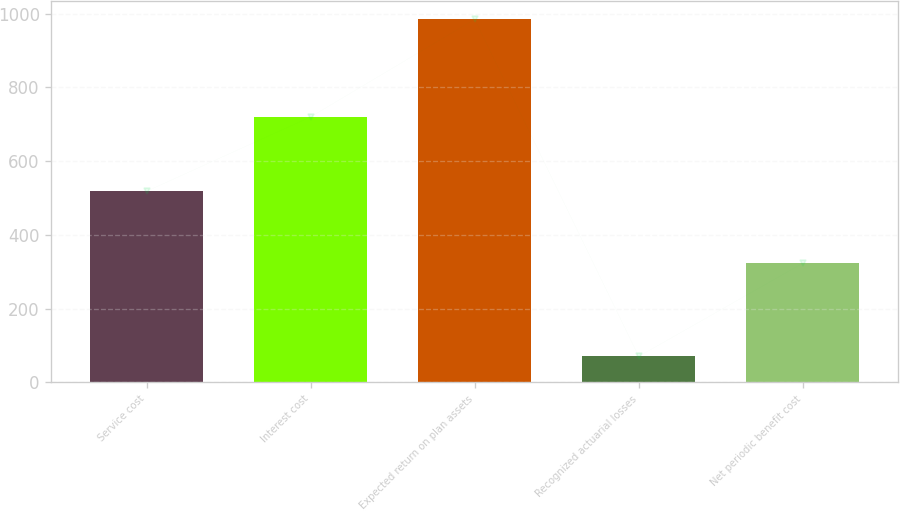Convert chart. <chart><loc_0><loc_0><loc_500><loc_500><bar_chart><fcel>Service cost<fcel>Interest cost<fcel>Expected return on plan assets<fcel>Recognized actuarial losses<fcel>Net periodic benefit cost<nl><fcel>518<fcel>720<fcel>985<fcel>70<fcel>323<nl></chart> 